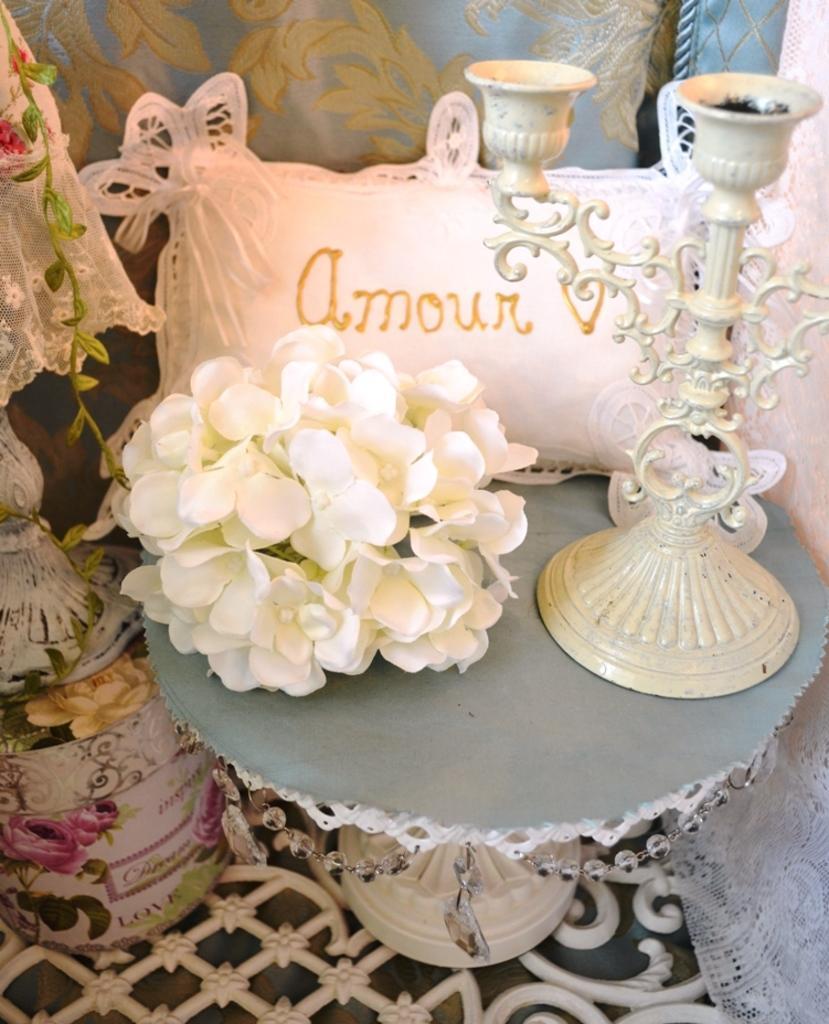Could you give a brief overview of what you see in this image? In the image we can see there are flowers, candle stand and there is a pillow kept on the table. There is a table lamp kept on the box and there are designs on the floor. Behind there is a curtain. 